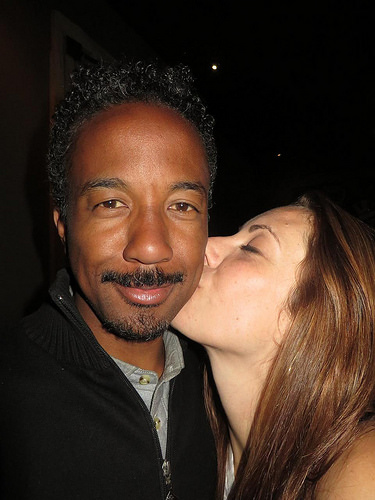<image>
Is the man in the woman? No. The man is not contained within the woman. These objects have a different spatial relationship. 